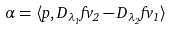<formula> <loc_0><loc_0><loc_500><loc_500>\alpha = \langle p , D _ { \lambda _ { 1 } } f v _ { 2 } - D _ { \lambda _ { 2 } } f v _ { 1 } \rangle</formula> 